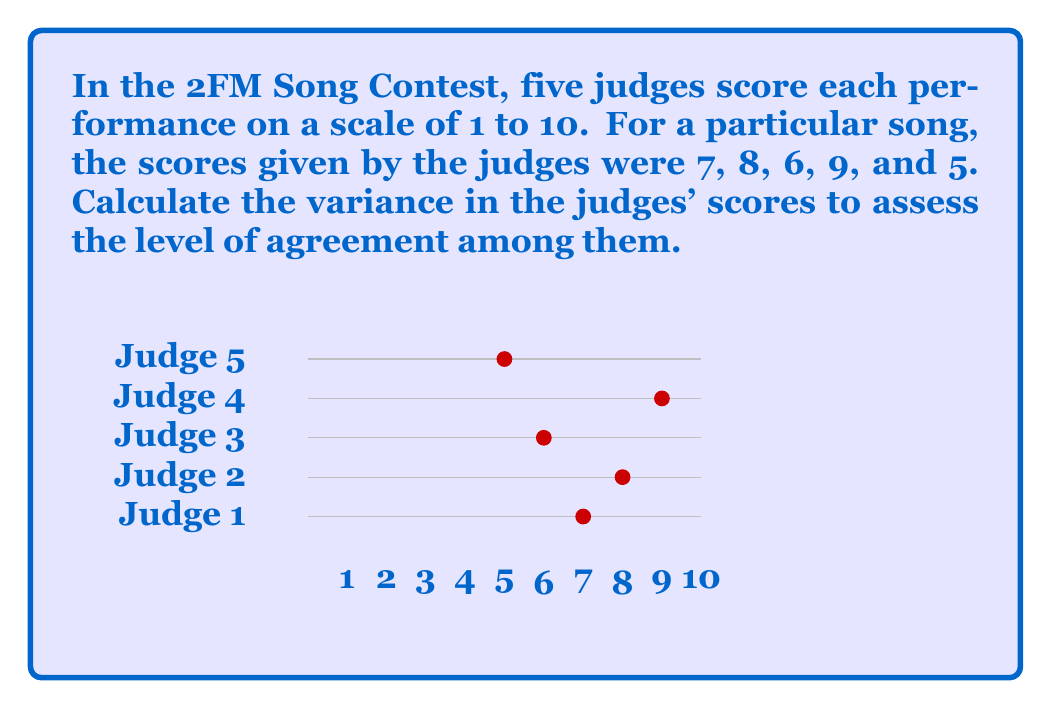Can you solve this math problem? To calculate the variance, we'll follow these steps:

1) First, calculate the mean score:
   $$\bar{x} = \frac{7 + 8 + 6 + 9 + 5}{5} = 7$$

2) Calculate the squared differences from the mean:
   $$(7-7)^2 = 0$$
   $$(8-7)^2 = 1$$
   $$(6-7)^2 = 1$$
   $$(9-7)^2 = 4$$
   $$(5-7)^2 = 4$$

3) Sum these squared differences:
   $$0 + 1 + 1 + 4 + 4 = 10$$

4) Divide by the number of scores (n) to get the variance:
   $$\text{Variance} = \frac{\sum(x_i - \bar{x})^2}{n} = \frac{10}{5} = 2$$

Therefore, the variance in the judges' scores is 2.
Answer: $2$ 